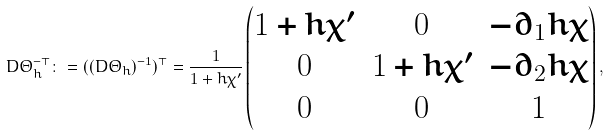<formula> <loc_0><loc_0><loc_500><loc_500>D \Theta _ { h } ^ { - \top } \colon = ( ( D \Theta _ { h } ) ^ { - 1 } ) ^ { \top } = \frac { 1 } { 1 + h \chi ^ { \prime } } \begin{pmatrix} 1 + h \chi ^ { \prime } & 0 & - \partial _ { 1 } h \chi \\ 0 & 1 + h \chi ^ { \prime } & - \partial _ { 2 } h \chi \\ 0 & 0 & 1 \end{pmatrix} ,</formula> 